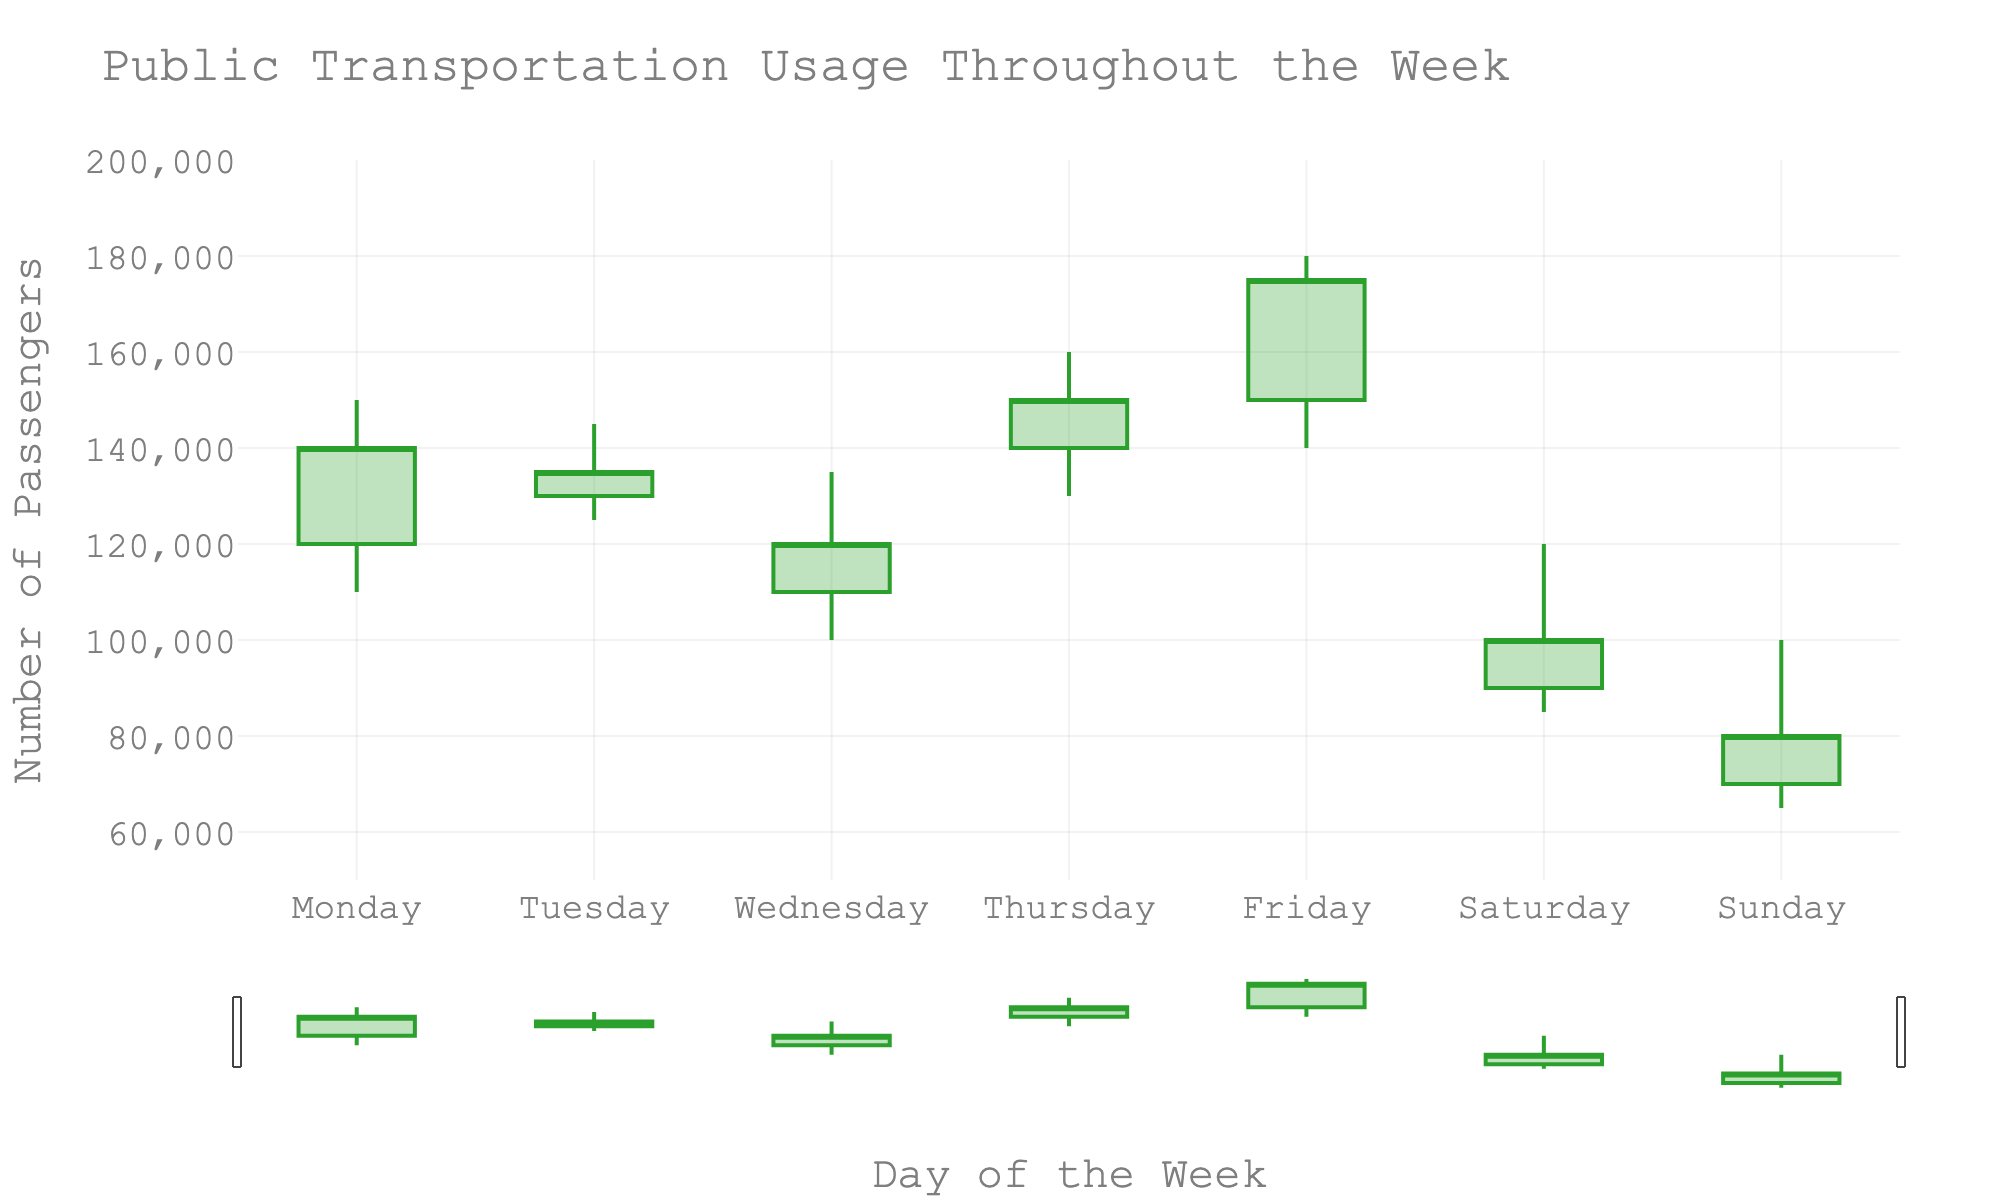what is the title of the plot? The title of a plot is usually mentioned at the top. In this case, the title is clearly written at the top of the figure.
Answer: Public Transportation Usage Throughout the Week What does the y-axis represent? The y-axis typically represents the variable being measured or counted. The title of the y-axis will usually provide this information. Here, it is labeled "Number of Passengers."
Answer: Number of Passengers On which day is the highest number of passengers recorded? To find the highest number of passengers, we need to look for the highest value on the y-axis across all days. The 'High' value for Friday is the highest at 180,000 passengers.
Answer: Friday What is the range of the y-axis? The range of the y-axis is determined by the smallest and largest values it can represent. In this plot, the y-axis starts at 50,000 and goes up to 200,000.
Answer: 50,000 to 200,000 How many days show a decrease in the number of passengers from open to close? Analyzing each candlestick: if the close value is less than the open value, it indicates a decrease. Here, Tuesday, Wednesday, and Saturday show a decrease.
Answer: 3 Which days show an increase from the lowest value to the highest value? To find the days with the largest growth from low to high, we look for the maximum difference between the 'High' and 'Low' values. For Thursday, Friday, and Tuesday, the 'High' value is significantly more than the 'Low'.
Answer: Thursday, Friday, Tuesday Which day has the largest range in passenger numbers (high minus low)? To find the largest range, we subtract the 'Low' value from the 'High' value for each day and find the maximum. For Friday, this range is 40,000 (180,000 - 140,000).
Answer: Friday Is the passenger count higher or lower on the weekend compared to weekdays? To answer this, compare the 'Close' values of Saturday and Sunday to the average 'Close' values of Monday to Friday. The weekend values (100,000 and 80,000) are lower compared to the weekday average (136,000).
Answer: Lower What is the average number of passengers on weekdays (Monday to Friday)? Calculate the average by summing up the 'Close' values for Monday to Friday (140,000 + 135,000 + 120,000 + 150,000 + 175,000) and dividing by 5. The average is 720,000/5 = 144,000.
Answer: 144,000 What is the difference in the number of passengers between Thursday and Sunday? Subtract the 'Close' value of Sunday from the 'Close' value of Thursday. The difference is 150,000 - 80,000 = 70,000.
Answer: 70,000 